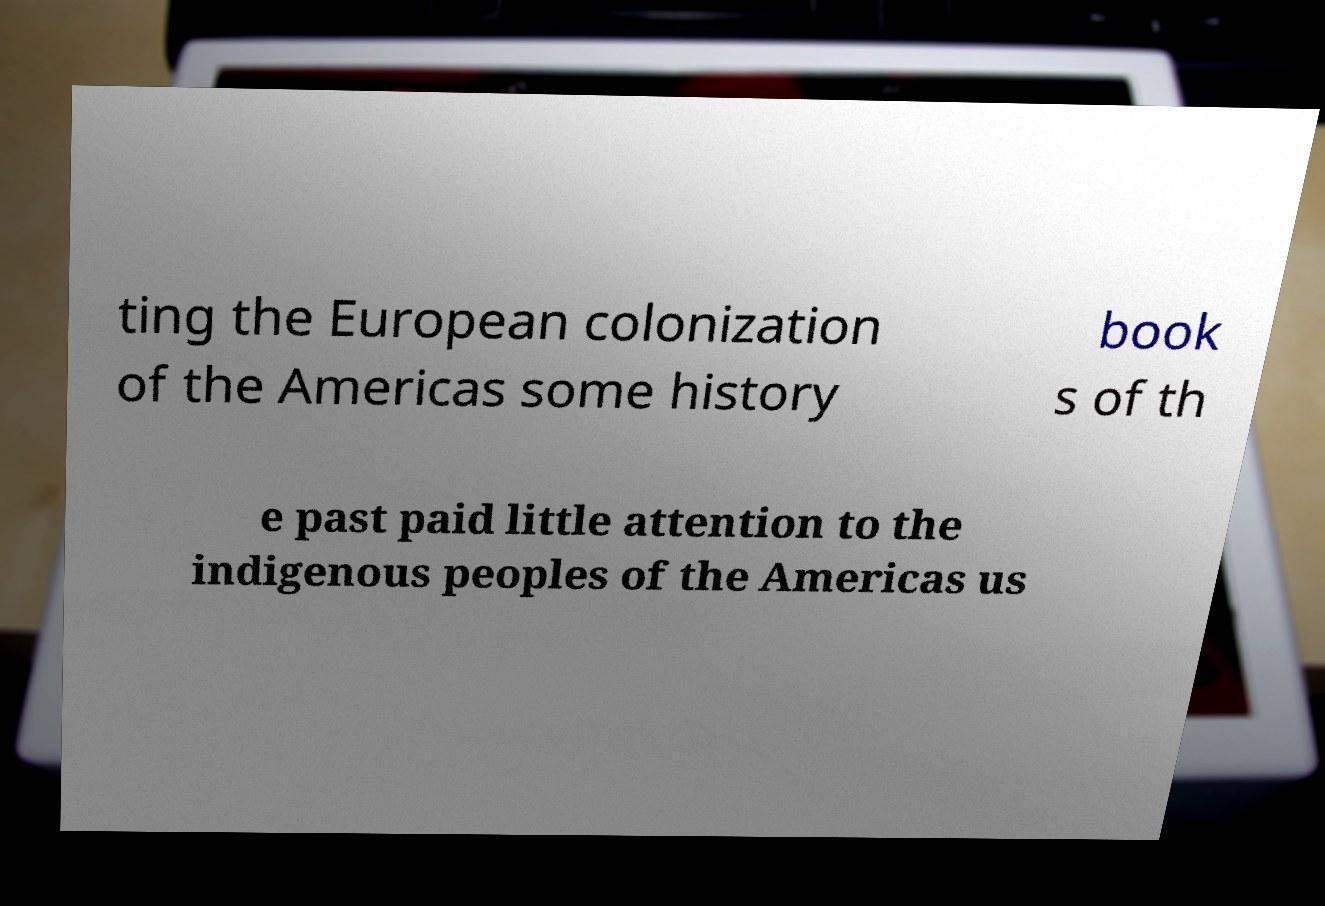I need the written content from this picture converted into text. Can you do that? ting the European colonization of the Americas some history book s of th e past paid little attention to the indigenous peoples of the Americas us 